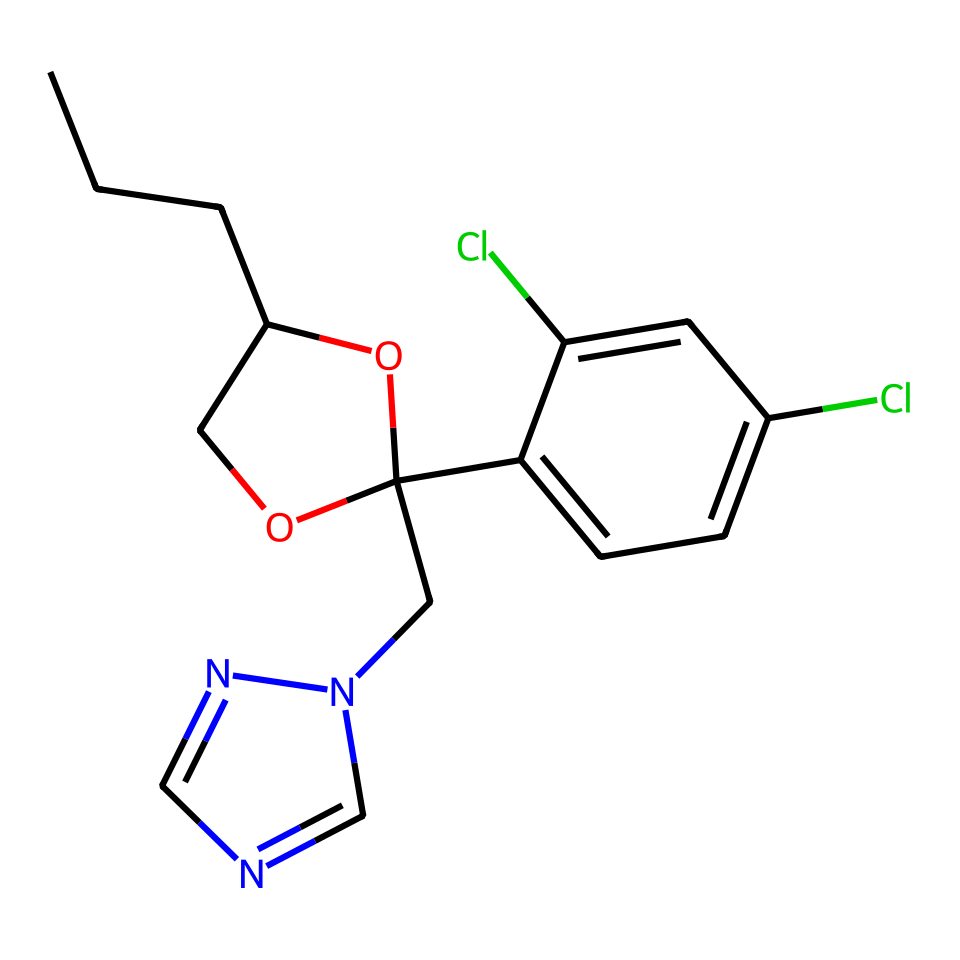What is the full name of the compound represented by this SMILES? The SMILES representation indicates a chemical structure that corresponds to the compound Propiconazole, which is a fungicide.
Answer: Propiconazole How many chlorine atoms are present in this molecule? By examining the chemical structure: the visual representation from the SMILES indicates two chlorine atoms, which are represented by "Cl" in the structure.
Answer: two How many carbon atoms are in the structure of propiconazole? In the provided SMILES, the "C" letters represent carbon atoms; counting them in the structure shows that there are 14 carbon atoms in propiconazole.
Answer: fourteen What functional group is indicated by the "O" in the structure? The "O" in the chemical structure indicates the presence of an alcohol group (-OH), as it connects to a carbon atom and is part of the cyclic structure.
Answer: alcohol Does propiconazole contain any nitrogen atoms? The analysis of the SMILES reveals there are two nitrogen atoms indicated by "n" in the structure, confirming its presence in propiconazole.
Answer: yes What effect might the chlorine atoms have on the properties of propiconazole? Chlorine typically enhances the antifungal potency of compounds, suggesting that the chlorinated structure of propiconazole may increase its effectiveness as a fungicide.
Answer: increase antifungal potency Is propiconazole primarily a systemic or contact fungicide? Based on its chemical structure and mechanisms of action, propiconazole is primarily classified as a systemic fungicide, meaning it can be absorbed and translocated within plant tissues.
Answer: systemic 